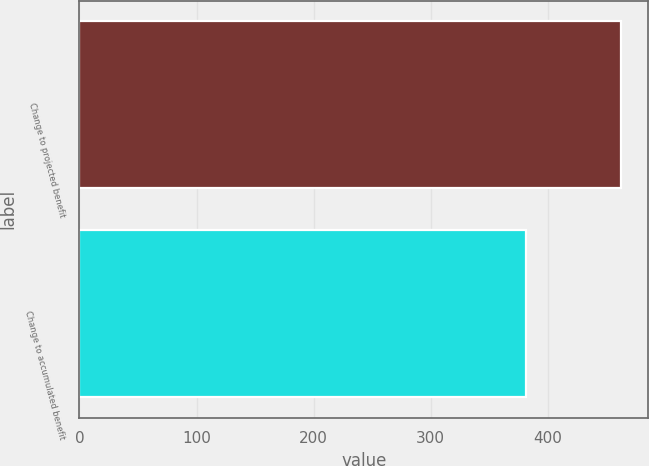Convert chart. <chart><loc_0><loc_0><loc_500><loc_500><bar_chart><fcel>Change to projected benefit<fcel>Change to accumulated benefit<nl><fcel>463<fcel>382<nl></chart> 